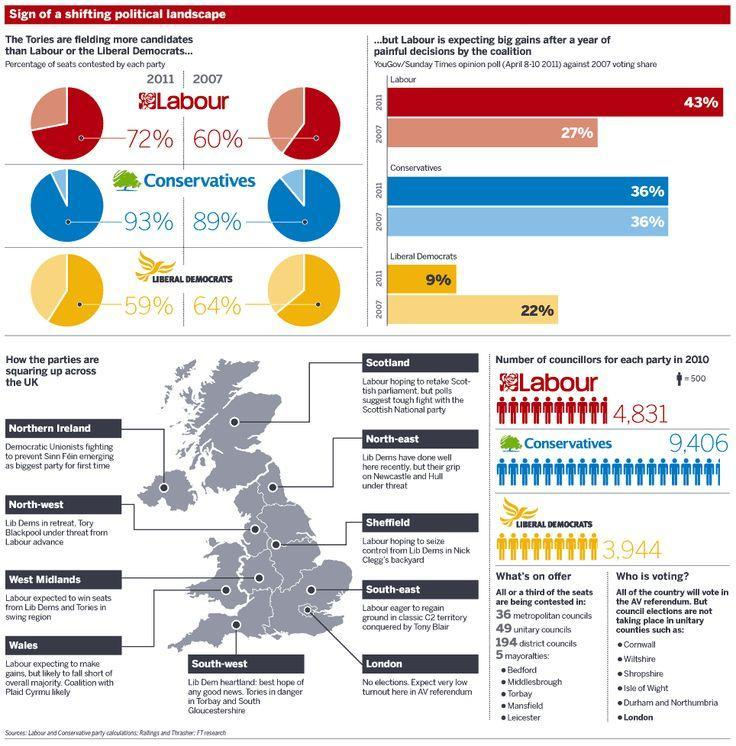In which place does the Labour party see a tough fight against Scottish National Party?
Answer the question with a short phrase. Scotland Which party has highest number of councillors in 2010? Conservatives Which party sees an increase in voting share in 2011 compared to 2007? Labour Which party has lesser percent of seats in 2011 compared to 2007? Liberal democrats In which place elections will not be taking place - Wales, London or Sheffield? London 